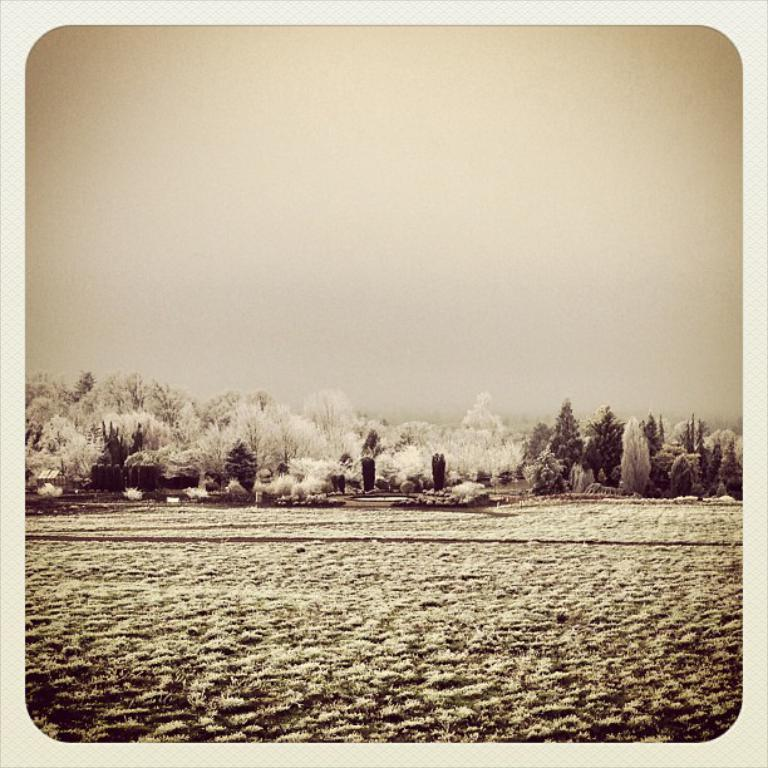What type of vegetation is present at the bottom of the image? There is grass on the ground at the bottom of the image. What can be seen in the middle of the image? There are plants and trees in the middle of the image. What is visible at the top of the image? The sky is visible at the top of the image. What hobbies are the plants and trees participating in during the day? Plants and trees do not have hobbies, and the image does not indicate a specific time of day. 